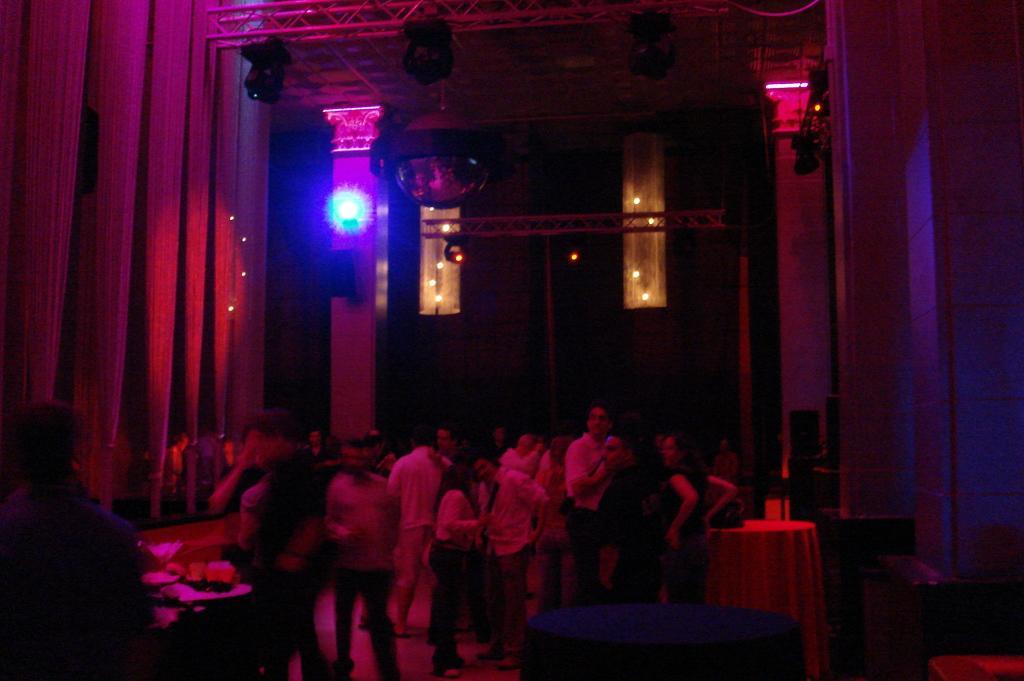Could you give a brief overview of what you see in this image? In this image we can see people standing on the floor, electric lights, grills and food placed on the table. 